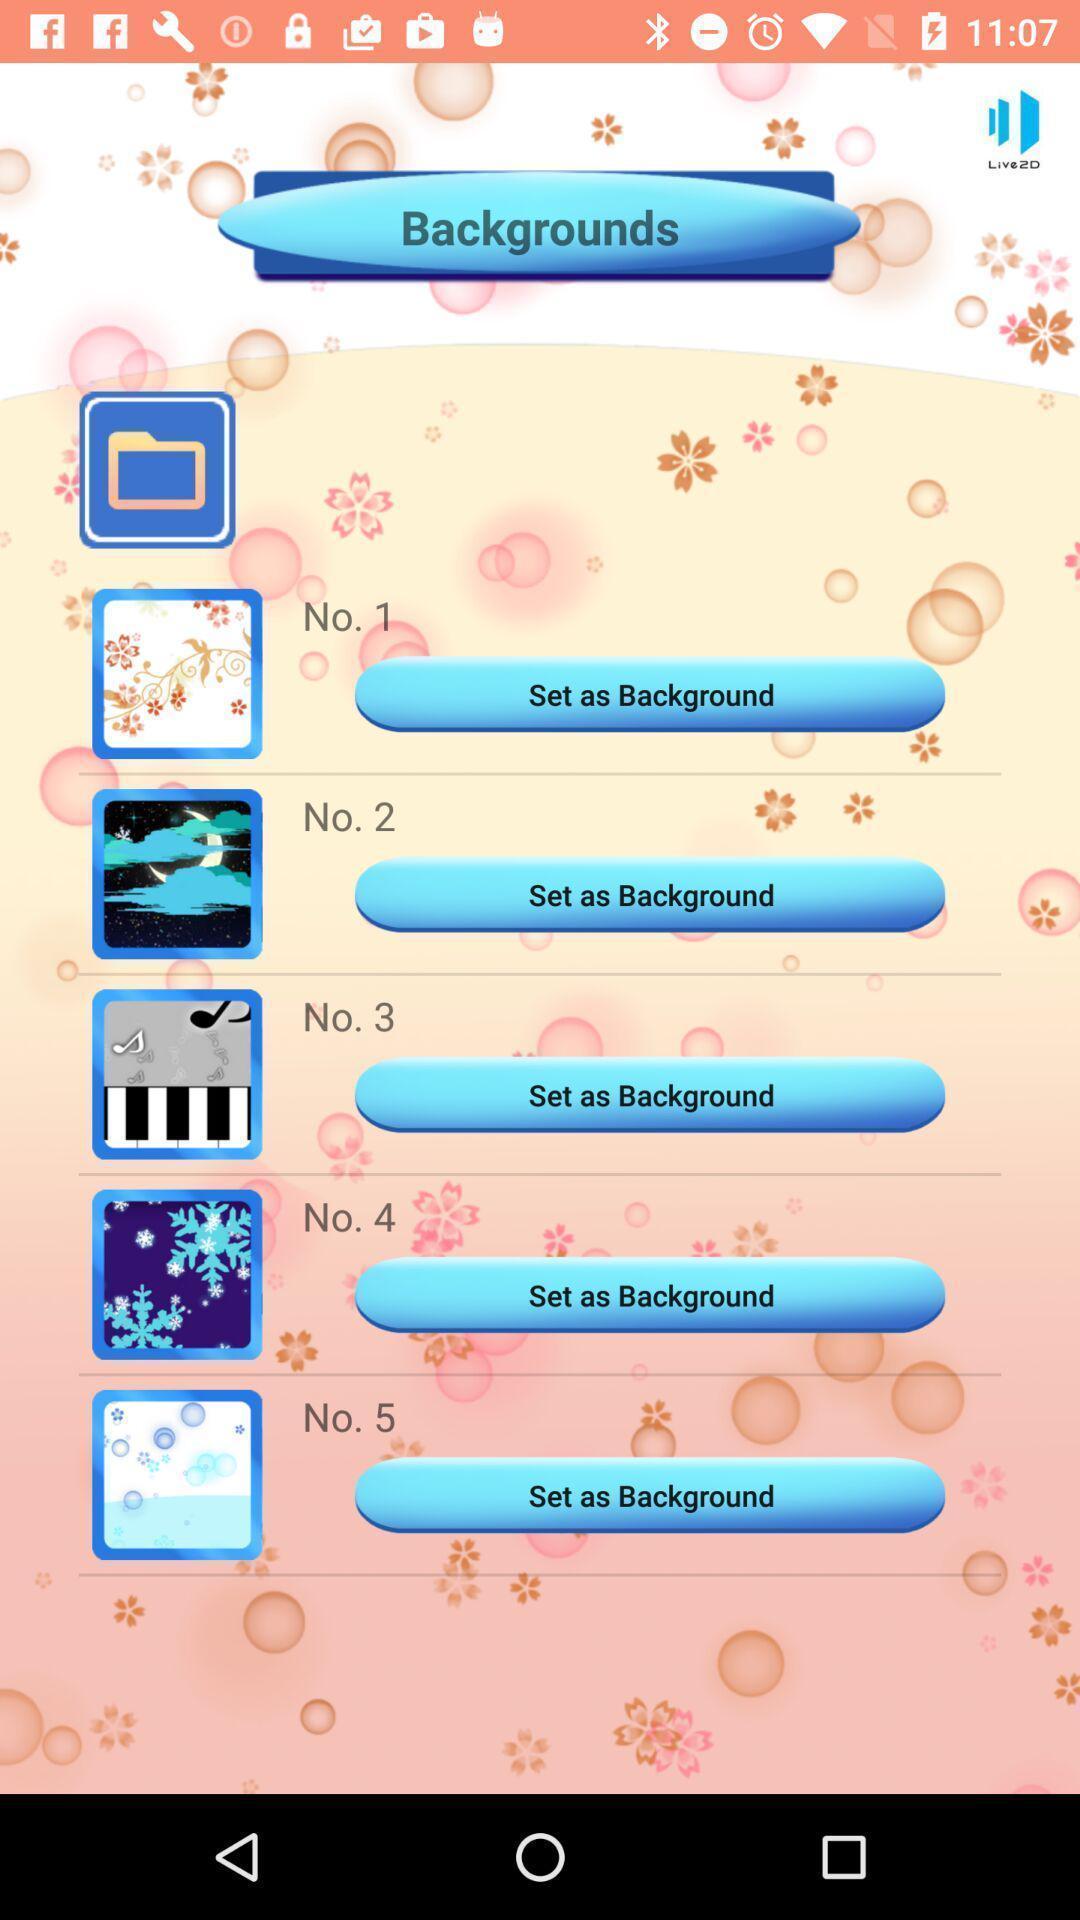What is the overall content of this screenshot? Screen showing options to set background. 